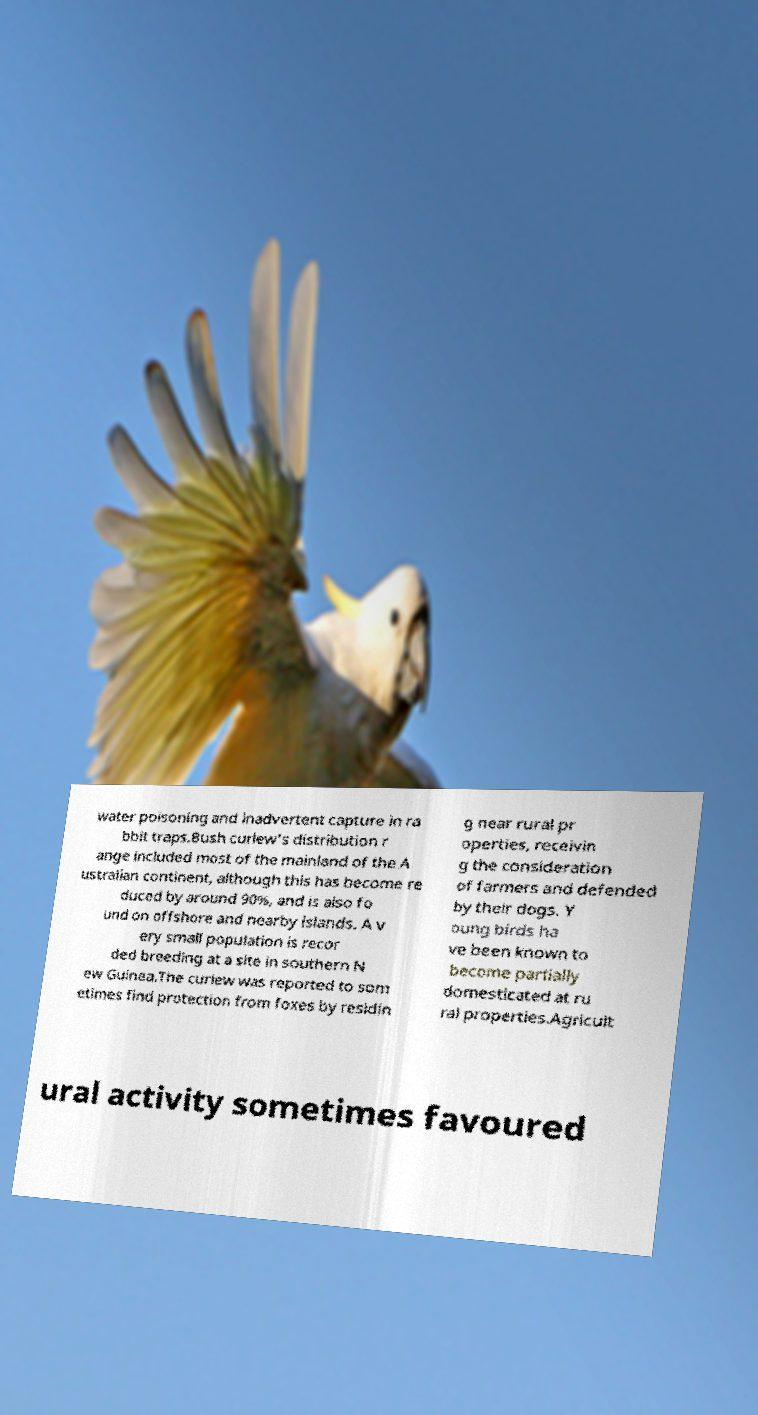Could you assist in decoding the text presented in this image and type it out clearly? water poisoning and inadvertent capture in ra bbit traps.Bush curlew's distribution r ange included most of the mainland of the A ustralian continent, although this has become re duced by around 90%, and is also fo und on offshore and nearby islands. A v ery small population is recor ded breeding at a site in southern N ew Guinea.The curlew was reported to som etimes find protection from foxes by residin g near rural pr operties, receivin g the consideration of farmers and defended by their dogs. Y oung birds ha ve been known to become partially domesticated at ru ral properties.Agricult ural activity sometimes favoured 